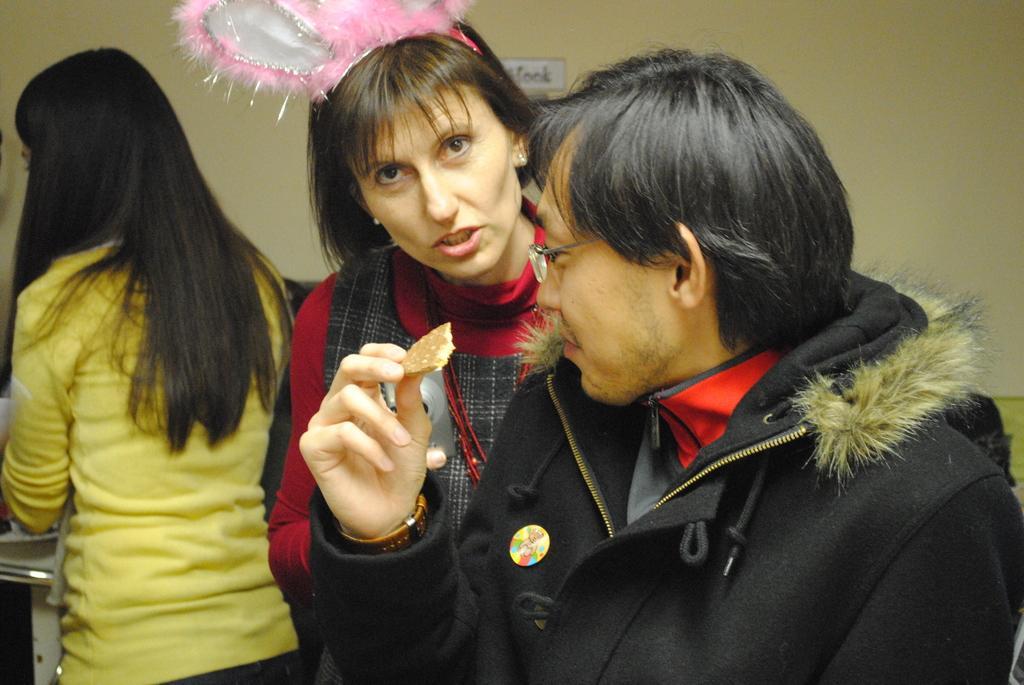In one or two sentences, can you explain what this image depicts? In this image we can see there are three people standing, one of them is holding a biscuit in his hand. In the background there is a wall. 